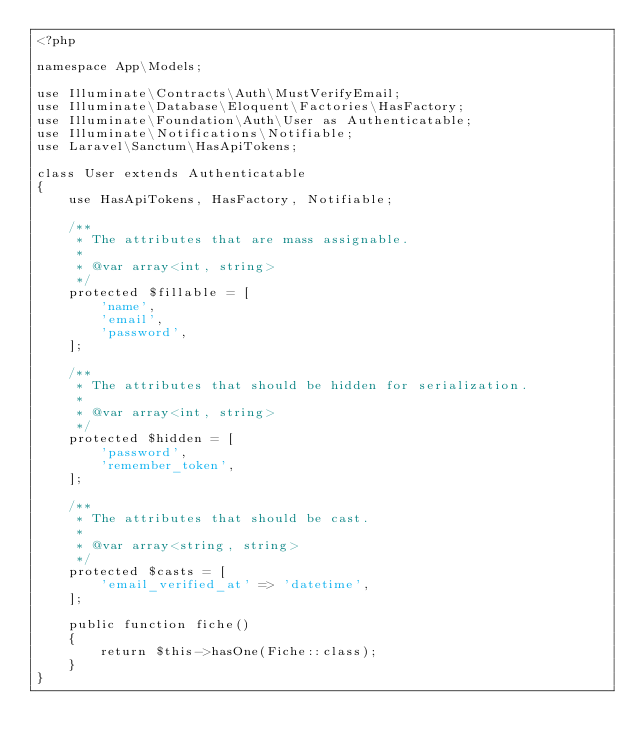Convert code to text. <code><loc_0><loc_0><loc_500><loc_500><_PHP_><?php

namespace App\Models;

use Illuminate\Contracts\Auth\MustVerifyEmail;
use Illuminate\Database\Eloquent\Factories\HasFactory;
use Illuminate\Foundation\Auth\User as Authenticatable;
use Illuminate\Notifications\Notifiable;
use Laravel\Sanctum\HasApiTokens;

class User extends Authenticatable
{
    use HasApiTokens, HasFactory, Notifiable;

    /**
     * The attributes that are mass assignable.
     *
     * @var array<int, string>
     */
    protected $fillable = [
        'name',
        'email',
        'password',
    ];

    /**
     * The attributes that should be hidden for serialization.
     *
     * @var array<int, string>
     */
    protected $hidden = [
        'password',
        'remember_token',
    ];

    /**
     * The attributes that should be cast.
     *
     * @var array<string, string>
     */
    protected $casts = [
        'email_verified_at' => 'datetime',
    ];

    public function fiche()
    {
        return $this->hasOne(Fiche::class);
    }
}
</code> 